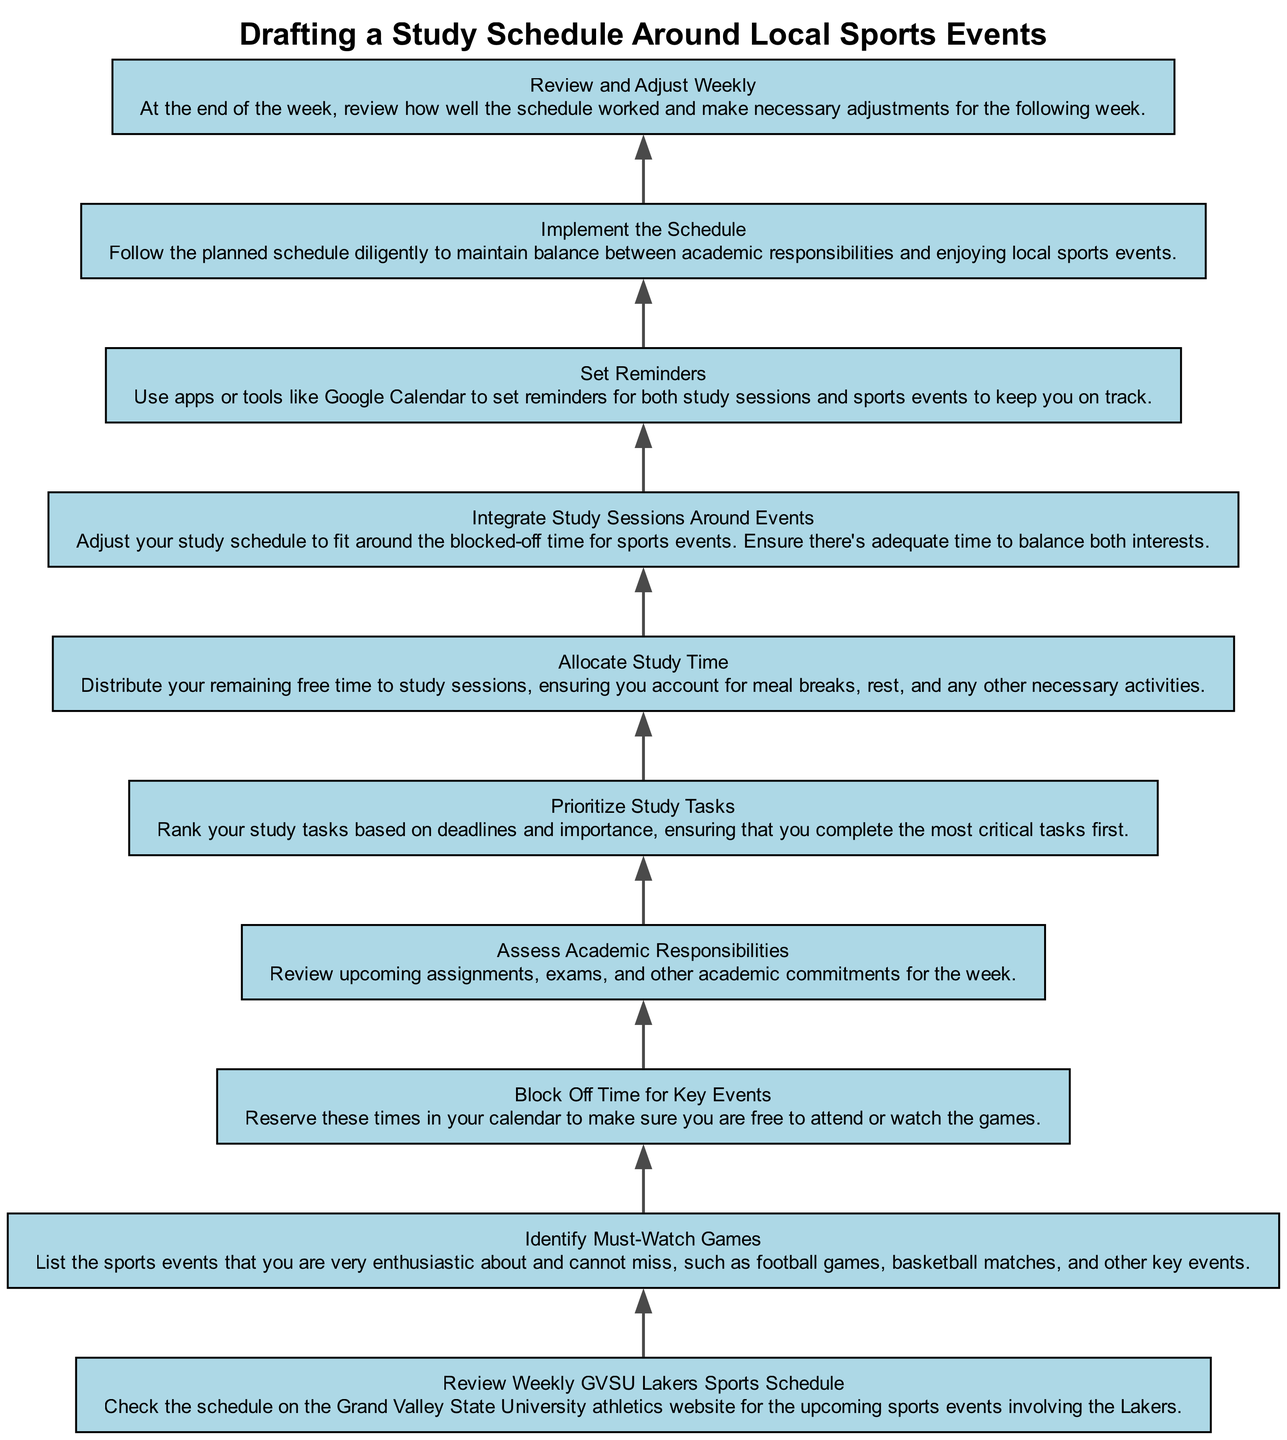What is the first step in the flow chart? The first step in the flow chart is to "Review Weekly GVSU Lakers Sports Schedule." This is the bottom-most node in the diagram, indicating it's the starting point for the process of drafting a study schedule around sports events.
Answer: Review Weekly GVSU Lakers Sports Schedule How many total elements are in the diagram? The diagram contains a total of 10 elements, as indicated by the number of nodes listed from the bottom to the top. Each element corresponds to a specific step in drafting a study schedule.
Answer: 10 What comes immediately after "Identify Must-Watch Games"? The step that comes immediately after "Identify Must-Watch Games" is "Block Off Time for Key Events." This can be deduced as it is the next node directly connected above "Identify Must-Watch Games".
Answer: Block Off Time for Key Events What is the last step of the process? The last step in the flow chart is "Review and Adjust Weekly," located at the top. This indicates that after implementing the schedule, the user should assess its effectiveness weekly.
Answer: Review and Adjust Weekly Which step involves examining academic commitments? The step that involves examining academic commitments is "Assess Academic Responsibilities." This step focuses on reviewing assignments, exams, and other commitments to plan effectively around them.
Answer: Assess Academic Responsibilities How do you integrate your study sessions with sports events? You integrate your study sessions with sports events by adjusting your study schedule to fit around the blocked-off time for these events, as stated in the step "Integrate Study Sessions Around Events." This means you consider the time for the games when planning your study hours.
Answer: Integrate Study Sessions Around Events What action should you take to set reminders? To set reminders, you should use tools or apps like Google Calendar, as indicated in the step "Set Reminders." This step emphasizes organization and keeping track of both study sessions and sports events.
Answer: Set Reminders Which elements must be prioritized in your study tasks? You must prioritize study tasks based on deadlines and importance in the step "Prioritize Study Tasks." This ensures you are focusing on completing critical tasks first.
Answer: Prioritize Study Tasks What adjustment is suggested at the week's end? At the week's end, the suggested adjustment is to "Review and Adjust Weekly," indicating that one should evaluate the effectiveness of the schedule and make necessary changes for the next week.
Answer: Review and Adjust Weekly 